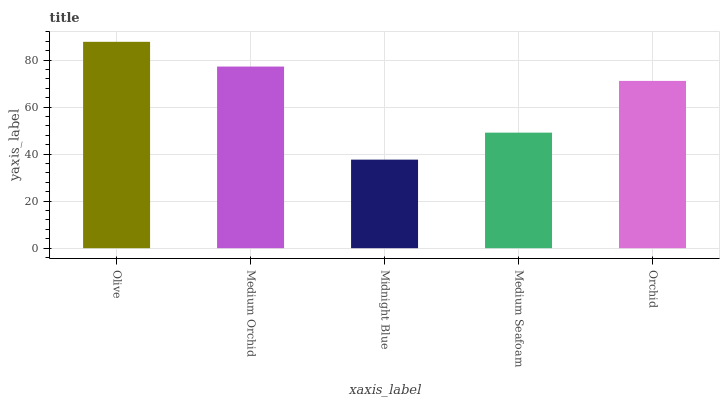Is Midnight Blue the minimum?
Answer yes or no. Yes. Is Olive the maximum?
Answer yes or no. Yes. Is Medium Orchid the minimum?
Answer yes or no. No. Is Medium Orchid the maximum?
Answer yes or no. No. Is Olive greater than Medium Orchid?
Answer yes or no. Yes. Is Medium Orchid less than Olive?
Answer yes or no. Yes. Is Medium Orchid greater than Olive?
Answer yes or no. No. Is Olive less than Medium Orchid?
Answer yes or no. No. Is Orchid the high median?
Answer yes or no. Yes. Is Orchid the low median?
Answer yes or no. Yes. Is Midnight Blue the high median?
Answer yes or no. No. Is Midnight Blue the low median?
Answer yes or no. No. 